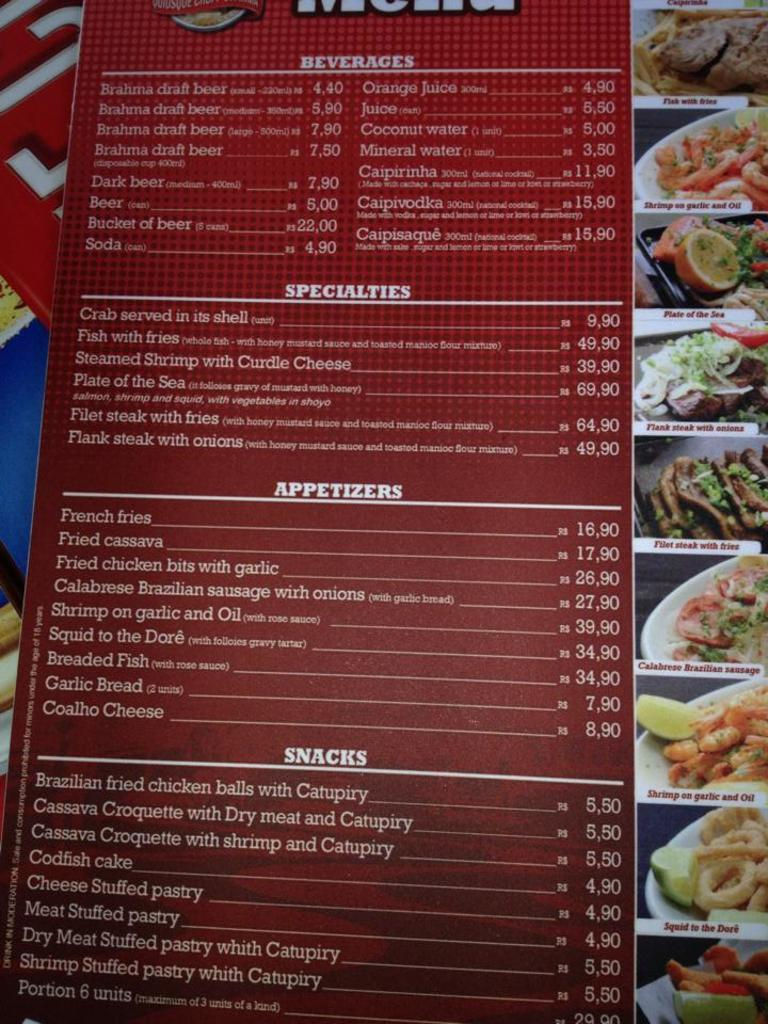What is the main object in the image? There is a menu card in the image. What information can be found on the menu card? The menu card contains different food items and displays the prices of the food items. What type of spark can be seen on the menu card in the image? There is no spark present on the menu card in the image. Can you tell me how many fictional food items are listed on the menu card? The menu card contains real food items, not fictional ones, so this question cannot be answered based on the information provided. 